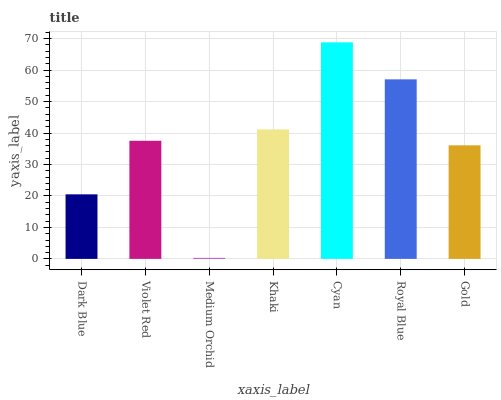Is Medium Orchid the minimum?
Answer yes or no. Yes. Is Cyan the maximum?
Answer yes or no. Yes. Is Violet Red the minimum?
Answer yes or no. No. Is Violet Red the maximum?
Answer yes or no. No. Is Violet Red greater than Dark Blue?
Answer yes or no. Yes. Is Dark Blue less than Violet Red?
Answer yes or no. Yes. Is Dark Blue greater than Violet Red?
Answer yes or no. No. Is Violet Red less than Dark Blue?
Answer yes or no. No. Is Violet Red the high median?
Answer yes or no. Yes. Is Violet Red the low median?
Answer yes or no. Yes. Is Dark Blue the high median?
Answer yes or no. No. Is Medium Orchid the low median?
Answer yes or no. No. 